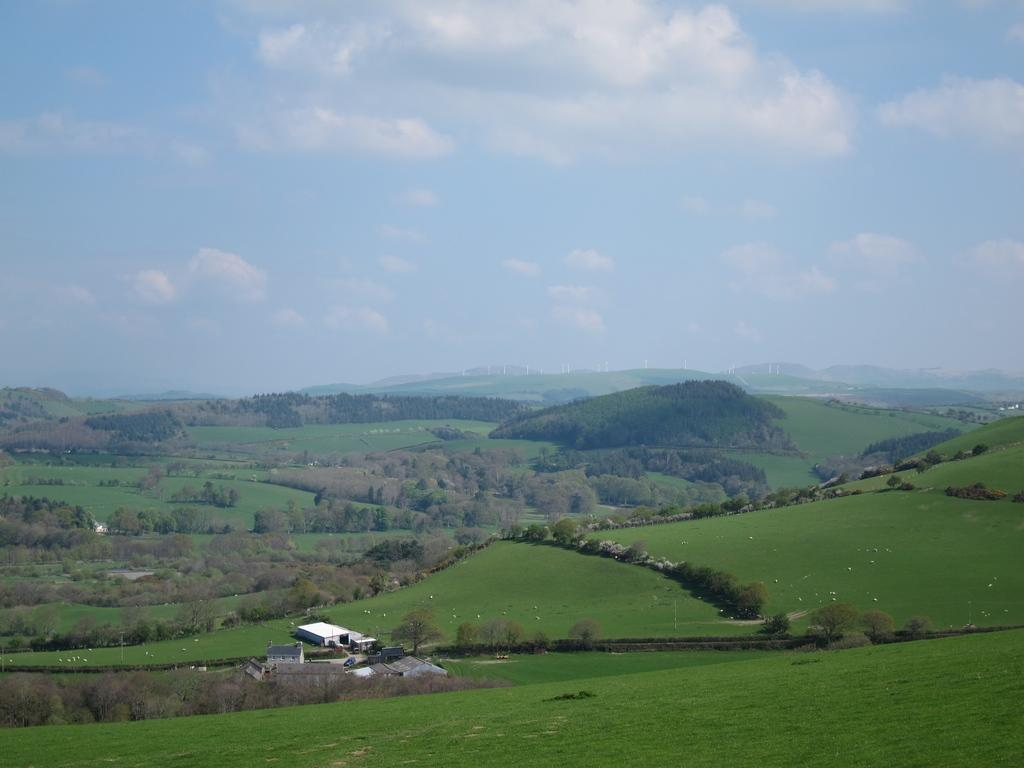What type of vegetation is present on the ground in the image? There is grass on the ground in the image. What type of structures can be seen in the image? There are sheds in the image. What other natural elements are visible in the image? There are trees in the image. What can be seen in the distance in the image? There are mountains visible in the background of the image. What is visible above the mountains in the image? The sky is visible in the background of the image. What is the condition of the sky in the image? Clouds are present in the sky. What type of sound can be heard coming from the yard in the image? There is no yard or sound present in the image; it features grass, sheds, trees, mountains, and a sky with clouds. 